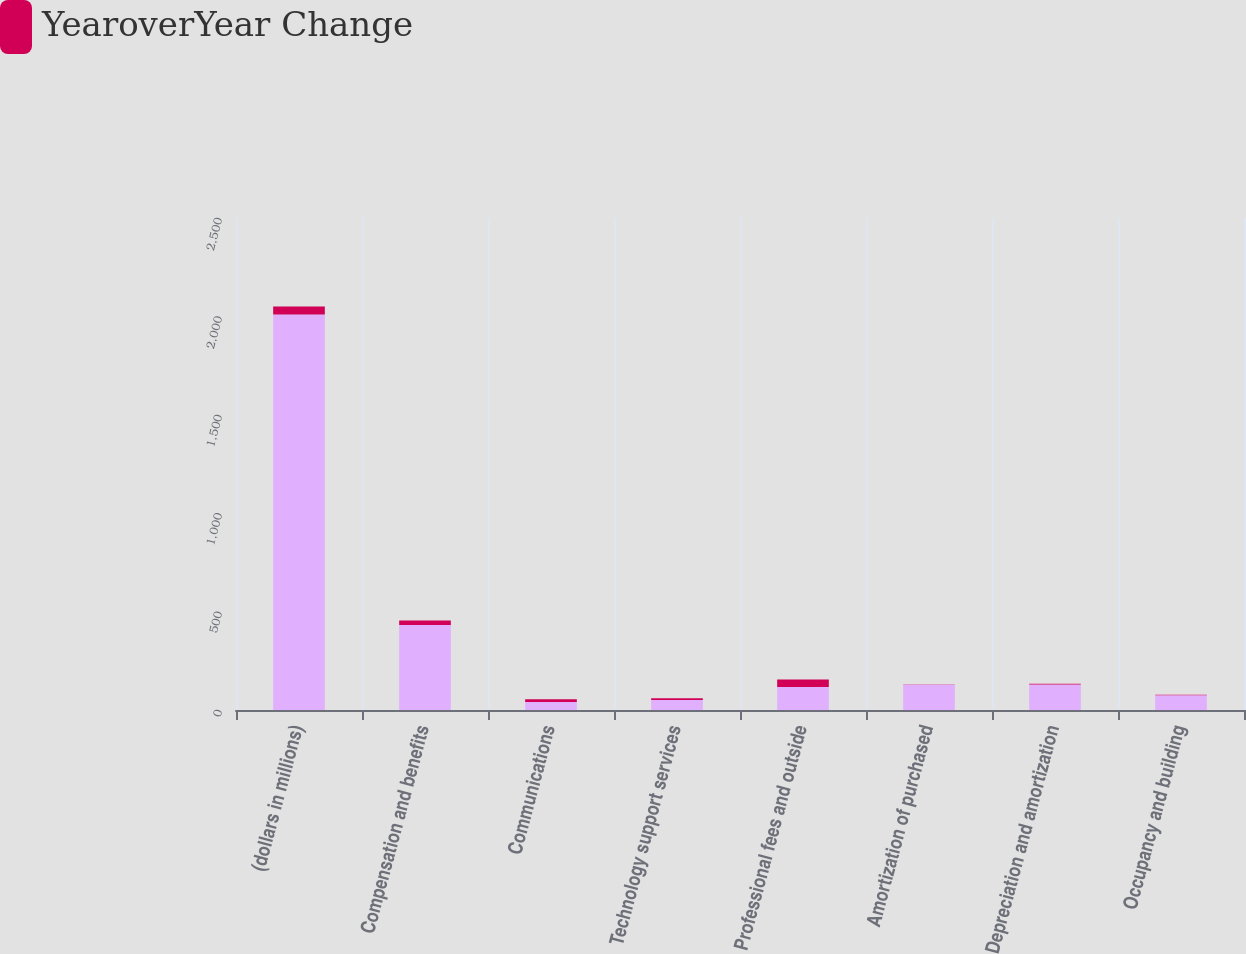Convert chart. <chart><loc_0><loc_0><loc_500><loc_500><stacked_bar_chart><ecel><fcel>(dollars in millions)<fcel>Compensation and benefits<fcel>Communications<fcel>Technology support services<fcel>Professional fees and outside<fcel>Amortization of purchased<fcel>Depreciation and amortization<fcel>Occupancy and building<nl><fcel>nan<fcel>2010<fcel>432.1<fcel>40.6<fcel>50.5<fcel>117.5<fcel>128.1<fcel>129.9<fcel>74.9<nl><fcel>YearoverYear Change<fcel>40.6<fcel>23<fcel>14<fcel>9<fcel>38<fcel>2<fcel>3<fcel>2<nl></chart> 